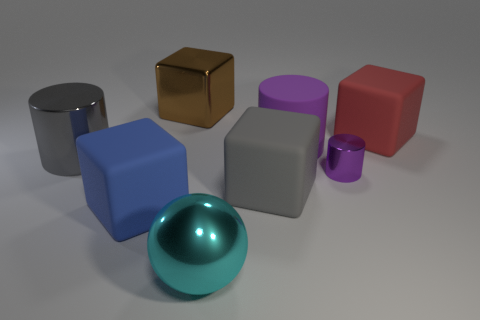What materials do the objects in the image appear to be made from? The objects present in the image appear to have different textures suggesting various materials. The sphere has a glossy finish that implies it might be made of polished metal or glass, whereas the cubes and cylinders have a matte finish that could suggest a metallic or plastic composition. 